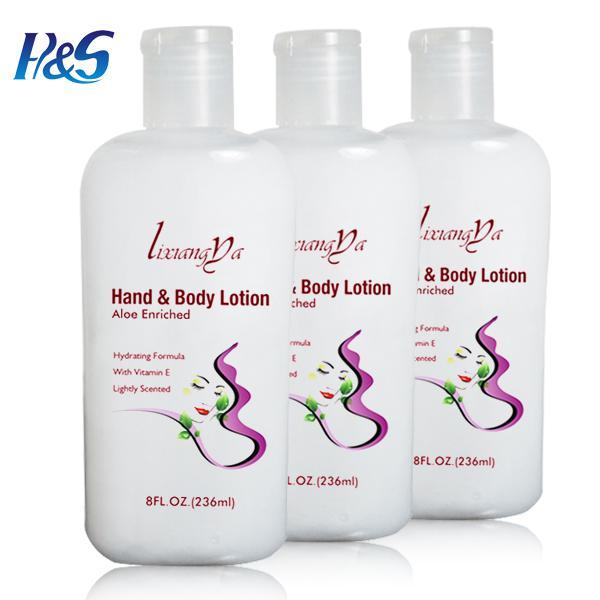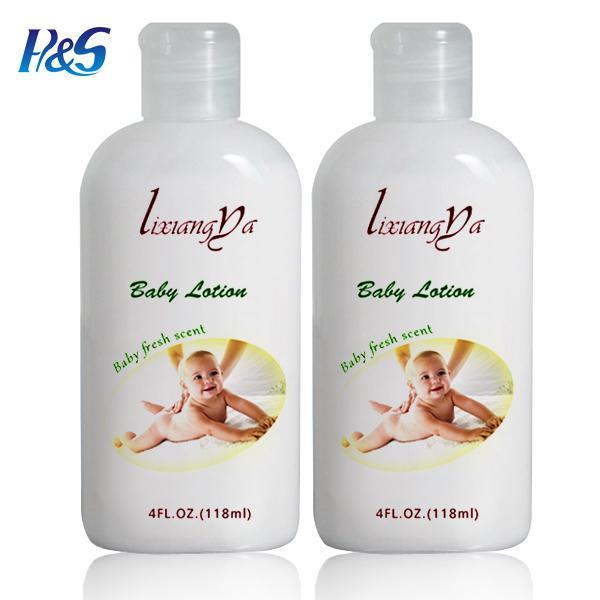The first image is the image on the left, the second image is the image on the right. For the images shown, is this caption "There are three bottles of lotion." true? Answer yes or no. No. 